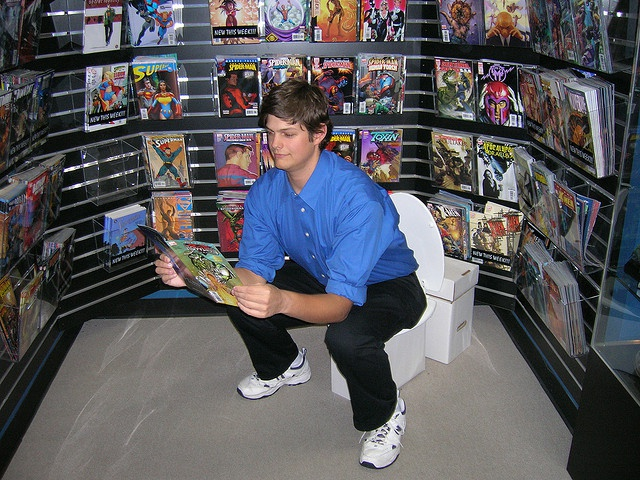Describe the objects in this image and their specific colors. I can see book in black, gray, darkgray, and navy tones, people in black, blue, and gray tones, toilet in black, lightgray, darkgray, and gray tones, book in black, darkgray, gray, and darkgreen tones, and book in black, gray, lightgray, and maroon tones in this image. 